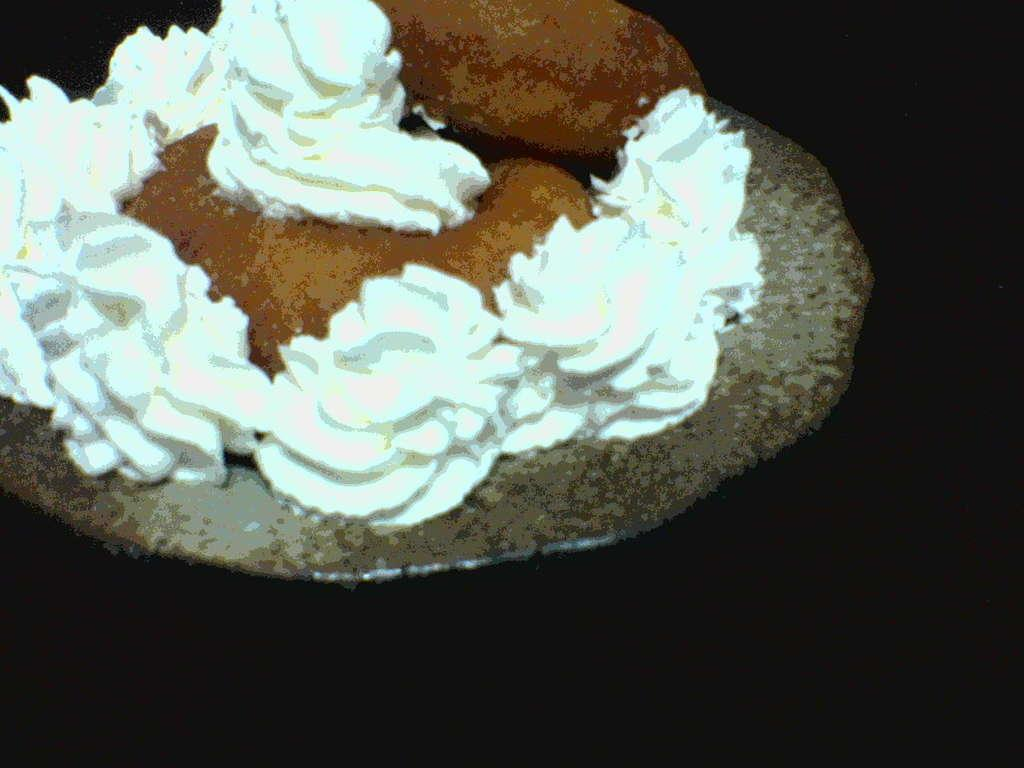What is depicted in the image? There is a painting of a cake in the image. What color is the cream on the cake in the painting? The painting of the cake has white-colored cream on it. What type of egg is causing trouble in the downtown area in the image? There is no egg, trouble, or downtown area present in the image; it only features a painting of a cake with white-colored cream. 